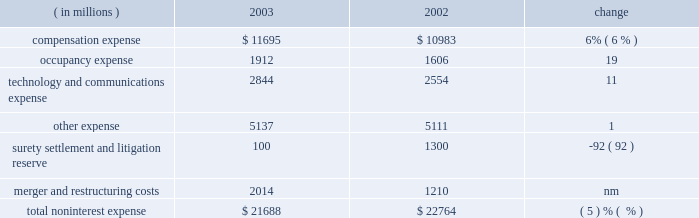Management 2019s discussion and analysis j.p .
Morgan chase & co .
26 j.p .
Morgan chase & co .
/ 2003 annual report $ 41.7 billion .
Nii was reduced by a lower volume of commercial loans and lower spreads on investment securities .
As a compo- nent of nii , trading-related net interest income of $ 2.1 billion was up 13% ( 13 % ) from 2002 due to a change in the composition of , and growth in , trading assets .
The firm 2019s total average interest-earning assets in 2003 were $ 590 billion , up 6% ( 6 % ) from the prior year .
The net interest yield on these assets , on a fully taxable-equivalent basis , was 2.10% ( 2.10 % ) , compared with 2.09% ( 2.09 % ) in the prior year .
Noninterest expense year ended december 31 .
Technology and communications expense in 2003 , technology and communications expense was 11% ( 11 % ) above the prior-year level .
The increase was primarily due to a shift in expenses : costs that were previously associated with compensation and other expenses shifted , upon the commence- ment of the ibm outsourcing agreement , to technology and communications expense .
Also contributing to the increase were higher costs related to software amortization .
For a further dis- cussion of the ibm outsourcing agreement , see support units and corporate on page 44 of this annual report .
Other expense other expense in 2003 rose slightly from the prior year , reflecting higher outside services .
For a table showing the components of other expense , see note 8 on page 96 of this annual report .
Surety settlement and litigation reserve the firm added $ 100 million to the enron-related litigation reserve in 2003 to supplement a $ 900 million reserve initially recorded in 2002 .
The 2002 reserve was established to cover enron-related matters , as well as certain other material litigation , proceedings and investigations in which the firm is involved .
In addition , in 2002 the firm recorded a charge of $ 400 million for the settlement of enron-related surety litigation .
Merger and restructuring costs merger and restructuring costs related to business restructurings announced after january 1 , 2002 , were recorded in their relevant expense categories .
In 2002 , merger and restructuring costs of $ 1.2 billion , for programs announced prior to january 1 , 2002 , were viewed by management as nonoperating expenses or 201cspecial items . 201d refer to note 8 on pages 95 201396 of this annual report for a further discussion of merger and restructuring costs and for a summary , by expense category and business segment , of costs incurred in 2003 and 2002 for programs announced after january 1 , 2002 .
Provision for credit losses the 2003 provision for credit losses was $ 2.8 billion lower than in 2002 , primarily reflecting continued improvement in the quality of the commercial loan portfolio and a higher volume of credit card securitizations .
For further information about the provision for credit losses and the firm 2019s management of credit risk , see the dis- cussions of net charge-offs associated with the commercial and consumer loan portfolios and the allowance for credit losses , on pages 63 201365 of this annual report .
Income tax expense income tax expense was $ 3.3 billion in 2003 , compared with $ 856 million in 2002 .
The effective tax rate in 2003 was 33% ( 33 % ) , compared with 34% ( 34 % ) in 2002 .
The tax rate decline was principally attributable to changes in the proportion of income subject to state and local taxes .
Compensation expense compensation expense in 2003 was 6% ( 6 % ) higher than in the prior year .
The increase principally reflected higher performance-related incentives , and higher pension and other postretirement benefit costs , primarily as a result of changes in actuarial assumptions .
For a detailed discussion of pension and other postretirement benefit costs , see note 6 on pages 89 201393 of this annual report .
The increase pertaining to incentives included $ 266 million as a result of adopting sfas 123 , and $ 120 million from the reversal in 2002 of previously accrued expenses for certain forfeitable key employ- ee stock awards , as discussed in note 7 on pages 93 201395 of this annual report .
Total compensation expense declined as a result of the transfer , beginning april 1 , 2003 , of 2800 employees to ibm in connection with a technology outsourcing agreement .
The total number of full-time equivalent employees at december 31 , 2003 was 93453 compared with 94335 at the prior year-end .
Occupancy expense occupancy expense of $ 1.9 billion rose 19% ( 19 % ) from 2002 .
The increase reflected costs of additional leased space in midtown manhattan and in the south and southwest regions of the united states ; higher real estate taxes in new york city ; and the cost of enhanced safety measures .
Also contributing to the increase were charges for unoccupied excess real estate of $ 270 million ; this compared with $ 120 million in 2002 , mostly in the third quarter of that year. .
What was the value of the firms interest earning assets in 2002 in millions? 
Computations: (590 * (100 / 6%))
Answer: 983333.33333. Management 2019s discussion and analysis j.p .
Morgan chase & co .
26 j.p .
Morgan chase & co .
/ 2003 annual report $ 41.7 billion .
Nii was reduced by a lower volume of commercial loans and lower spreads on investment securities .
As a compo- nent of nii , trading-related net interest income of $ 2.1 billion was up 13% ( 13 % ) from 2002 due to a change in the composition of , and growth in , trading assets .
The firm 2019s total average interest-earning assets in 2003 were $ 590 billion , up 6% ( 6 % ) from the prior year .
The net interest yield on these assets , on a fully taxable-equivalent basis , was 2.10% ( 2.10 % ) , compared with 2.09% ( 2.09 % ) in the prior year .
Noninterest expense year ended december 31 .
Technology and communications expense in 2003 , technology and communications expense was 11% ( 11 % ) above the prior-year level .
The increase was primarily due to a shift in expenses : costs that were previously associated with compensation and other expenses shifted , upon the commence- ment of the ibm outsourcing agreement , to technology and communications expense .
Also contributing to the increase were higher costs related to software amortization .
For a further dis- cussion of the ibm outsourcing agreement , see support units and corporate on page 44 of this annual report .
Other expense other expense in 2003 rose slightly from the prior year , reflecting higher outside services .
For a table showing the components of other expense , see note 8 on page 96 of this annual report .
Surety settlement and litigation reserve the firm added $ 100 million to the enron-related litigation reserve in 2003 to supplement a $ 900 million reserve initially recorded in 2002 .
The 2002 reserve was established to cover enron-related matters , as well as certain other material litigation , proceedings and investigations in which the firm is involved .
In addition , in 2002 the firm recorded a charge of $ 400 million for the settlement of enron-related surety litigation .
Merger and restructuring costs merger and restructuring costs related to business restructurings announced after january 1 , 2002 , were recorded in their relevant expense categories .
In 2002 , merger and restructuring costs of $ 1.2 billion , for programs announced prior to january 1 , 2002 , were viewed by management as nonoperating expenses or 201cspecial items . 201d refer to note 8 on pages 95 201396 of this annual report for a further discussion of merger and restructuring costs and for a summary , by expense category and business segment , of costs incurred in 2003 and 2002 for programs announced after january 1 , 2002 .
Provision for credit losses the 2003 provision for credit losses was $ 2.8 billion lower than in 2002 , primarily reflecting continued improvement in the quality of the commercial loan portfolio and a higher volume of credit card securitizations .
For further information about the provision for credit losses and the firm 2019s management of credit risk , see the dis- cussions of net charge-offs associated with the commercial and consumer loan portfolios and the allowance for credit losses , on pages 63 201365 of this annual report .
Income tax expense income tax expense was $ 3.3 billion in 2003 , compared with $ 856 million in 2002 .
The effective tax rate in 2003 was 33% ( 33 % ) , compared with 34% ( 34 % ) in 2002 .
The tax rate decline was principally attributable to changes in the proportion of income subject to state and local taxes .
Compensation expense compensation expense in 2003 was 6% ( 6 % ) higher than in the prior year .
The increase principally reflected higher performance-related incentives , and higher pension and other postretirement benefit costs , primarily as a result of changes in actuarial assumptions .
For a detailed discussion of pension and other postretirement benefit costs , see note 6 on pages 89 201393 of this annual report .
The increase pertaining to incentives included $ 266 million as a result of adopting sfas 123 , and $ 120 million from the reversal in 2002 of previously accrued expenses for certain forfeitable key employ- ee stock awards , as discussed in note 7 on pages 93 201395 of this annual report .
Total compensation expense declined as a result of the transfer , beginning april 1 , 2003 , of 2800 employees to ibm in connection with a technology outsourcing agreement .
The total number of full-time equivalent employees at december 31 , 2003 was 93453 compared with 94335 at the prior year-end .
Occupancy expense occupancy expense of $ 1.9 billion rose 19% ( 19 % ) from 2002 .
The increase reflected costs of additional leased space in midtown manhattan and in the south and southwest regions of the united states ; higher real estate taxes in new york city ; and the cost of enhanced safety measures .
Also contributing to the increase were charges for unoccupied excess real estate of $ 270 million ; this compared with $ 120 million in 2002 , mostly in the third quarter of that year. .
What would pre-tax interest income be , in billions , for 2003 , based on the return on interest bearing assets? 
Computations: ((2.10 / 100) * 590)
Answer: 12.39. 